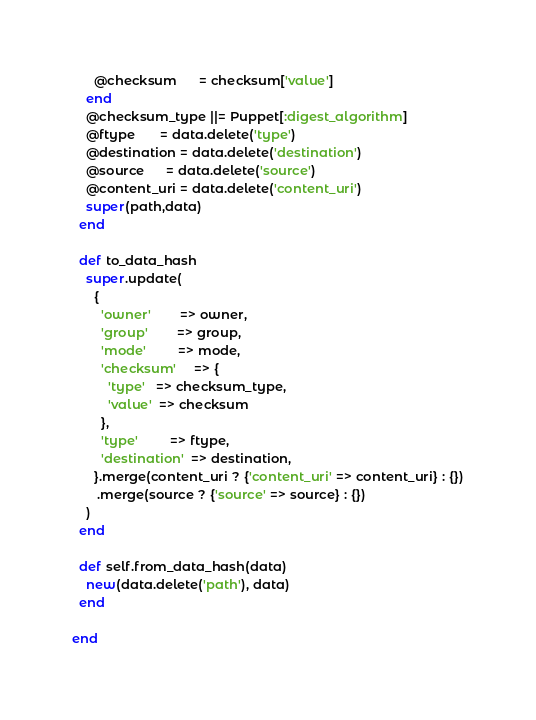<code> <loc_0><loc_0><loc_500><loc_500><_Ruby_>      @checksum      = checksum['value']
    end
    @checksum_type ||= Puppet[:digest_algorithm]
    @ftype       = data.delete('type')
    @destination = data.delete('destination')
    @source      = data.delete('source')
    @content_uri = data.delete('content_uri')
    super(path,data)
  end

  def to_data_hash
    super.update(
      {
        'owner'        => owner,
        'group'        => group,
        'mode'         => mode,
        'checksum'     => {
          'type'   => checksum_type,
          'value'  => checksum
        },
        'type'         => ftype,
        'destination'  => destination,
      }.merge(content_uri ? {'content_uri' => content_uri} : {})
       .merge(source ? {'source' => source} : {})
    )
  end

  def self.from_data_hash(data)
    new(data.delete('path'), data)
  end

end
</code> 